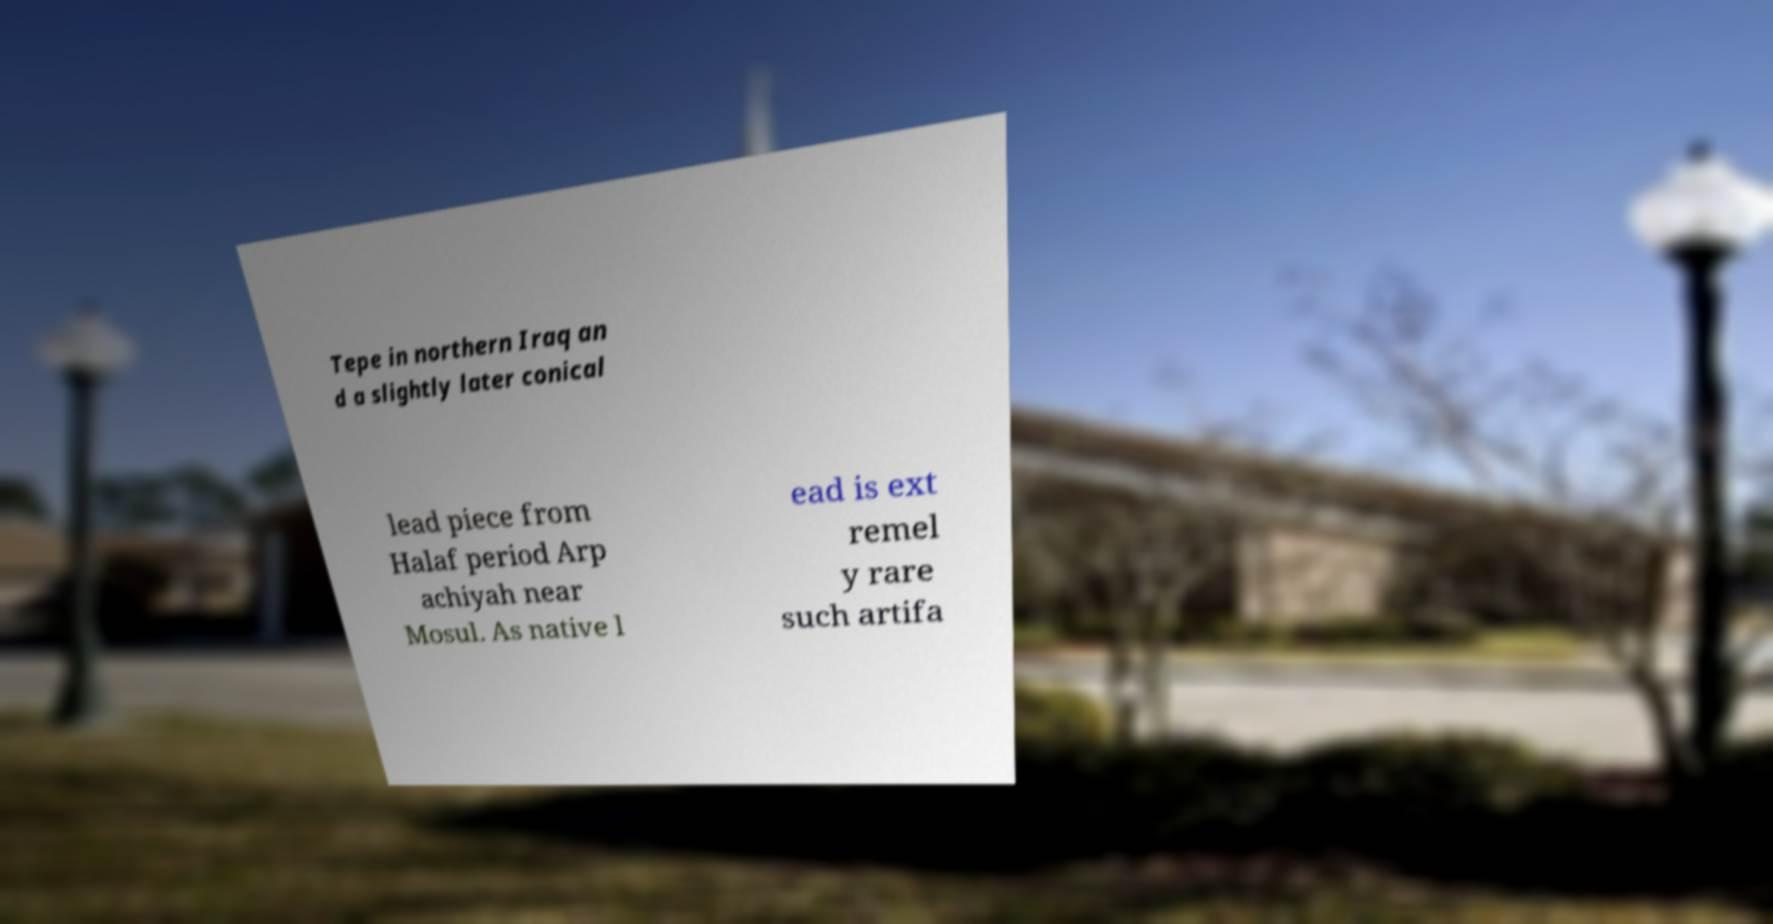Could you extract and type out the text from this image? Tepe in northern Iraq an d a slightly later conical lead piece from Halaf period Arp achiyah near Mosul. As native l ead is ext remel y rare such artifa 